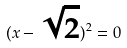Convert formula to latex. <formula><loc_0><loc_0><loc_500><loc_500>( x - \sqrt { 2 } ) ^ { 2 } = 0</formula> 